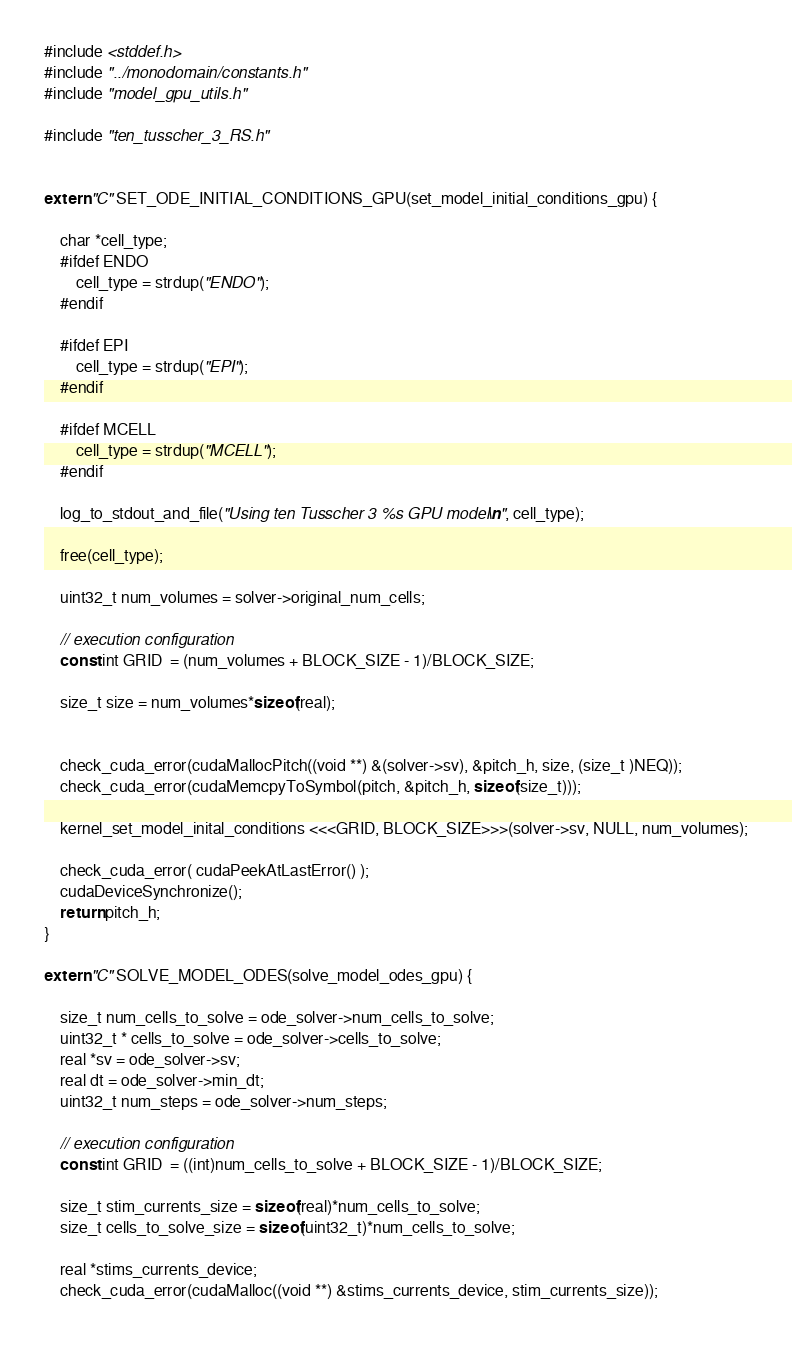<code> <loc_0><loc_0><loc_500><loc_500><_Cuda_>#include <stddef.h>
#include "../monodomain/constants.h"
#include "model_gpu_utils.h"

#include "ten_tusscher_3_RS.h"


extern "C" SET_ODE_INITIAL_CONDITIONS_GPU(set_model_initial_conditions_gpu) {

    char *cell_type;
    #ifdef ENDO
        cell_type = strdup("ENDO");
    #endif

    #ifdef EPI
        cell_type = strdup("EPI");
    #endif

    #ifdef MCELL
        cell_type = strdup("MCELL");
    #endif

    log_to_stdout_and_file("Using ten Tusscher 3 %s GPU model\n", cell_type);

    free(cell_type);

    uint32_t num_volumes = solver->original_num_cells;

    // execution configuration
    const int GRID  = (num_volumes + BLOCK_SIZE - 1)/BLOCK_SIZE;

    size_t size = num_volumes*sizeof(real);


    check_cuda_error(cudaMallocPitch((void **) &(solver->sv), &pitch_h, size, (size_t )NEQ));
    check_cuda_error(cudaMemcpyToSymbol(pitch, &pitch_h, sizeof(size_t)));

    kernel_set_model_inital_conditions <<<GRID, BLOCK_SIZE>>>(solver->sv, NULL, num_volumes);

    check_cuda_error( cudaPeekAtLastError() );
    cudaDeviceSynchronize();
    return pitch_h;
}

extern "C" SOLVE_MODEL_ODES(solve_model_odes_gpu) {

    size_t num_cells_to_solve = ode_solver->num_cells_to_solve;
    uint32_t * cells_to_solve = ode_solver->cells_to_solve;
    real *sv = ode_solver->sv;
    real dt = ode_solver->min_dt;
    uint32_t num_steps = ode_solver->num_steps;

    // execution configuration
    const int GRID  = ((int)num_cells_to_solve + BLOCK_SIZE - 1)/BLOCK_SIZE;

    size_t stim_currents_size = sizeof(real)*num_cells_to_solve;
    size_t cells_to_solve_size = sizeof(uint32_t)*num_cells_to_solve;

    real *stims_currents_device;
    check_cuda_error(cudaMalloc((void **) &stims_currents_device, stim_currents_size));</code> 